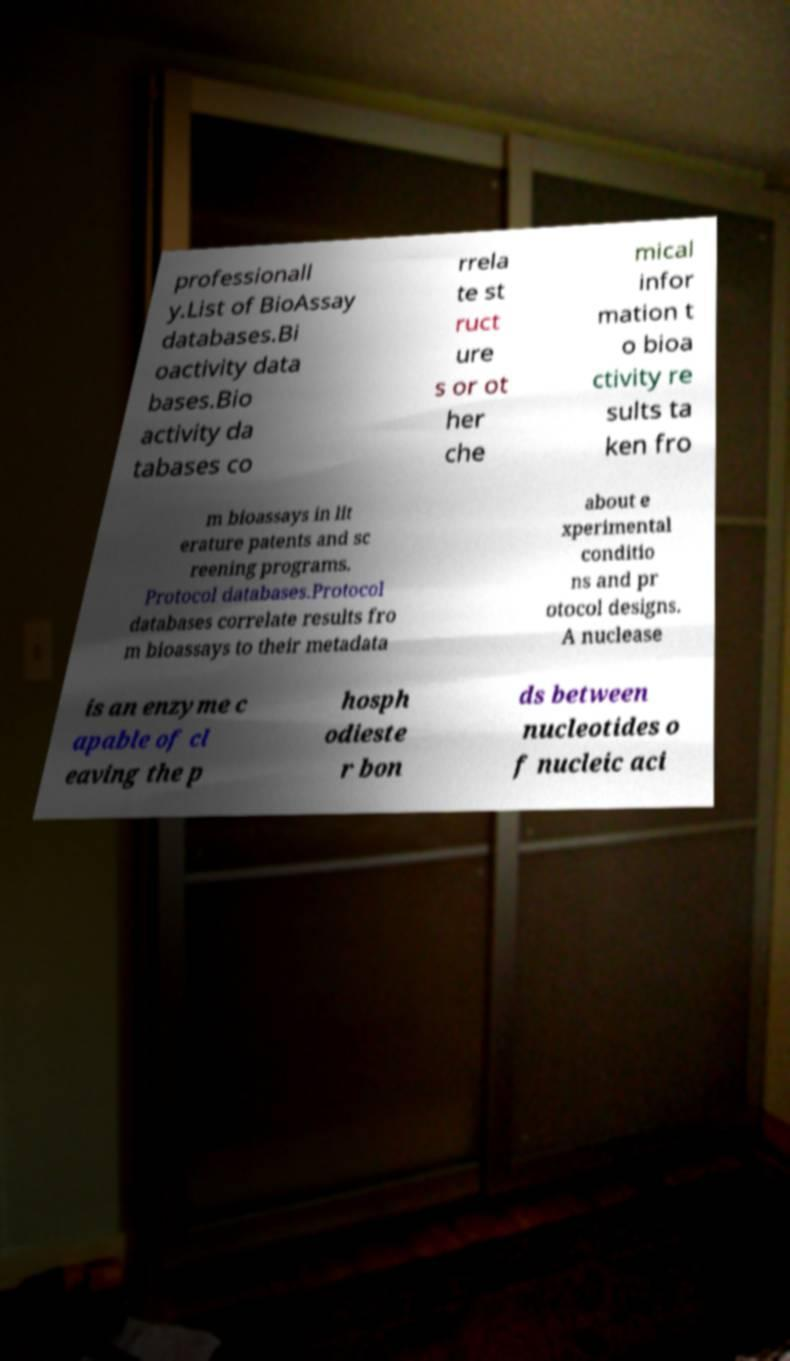What messages or text are displayed in this image? I need them in a readable, typed format. professionall y.List of BioAssay databases.Bi oactivity data bases.Bio activity da tabases co rrela te st ruct ure s or ot her che mical infor mation t o bioa ctivity re sults ta ken fro m bioassays in lit erature patents and sc reening programs. Protocol databases.Protocol databases correlate results fro m bioassays to their metadata about e xperimental conditio ns and pr otocol designs. A nuclease is an enzyme c apable of cl eaving the p hosph odieste r bon ds between nucleotides o f nucleic aci 